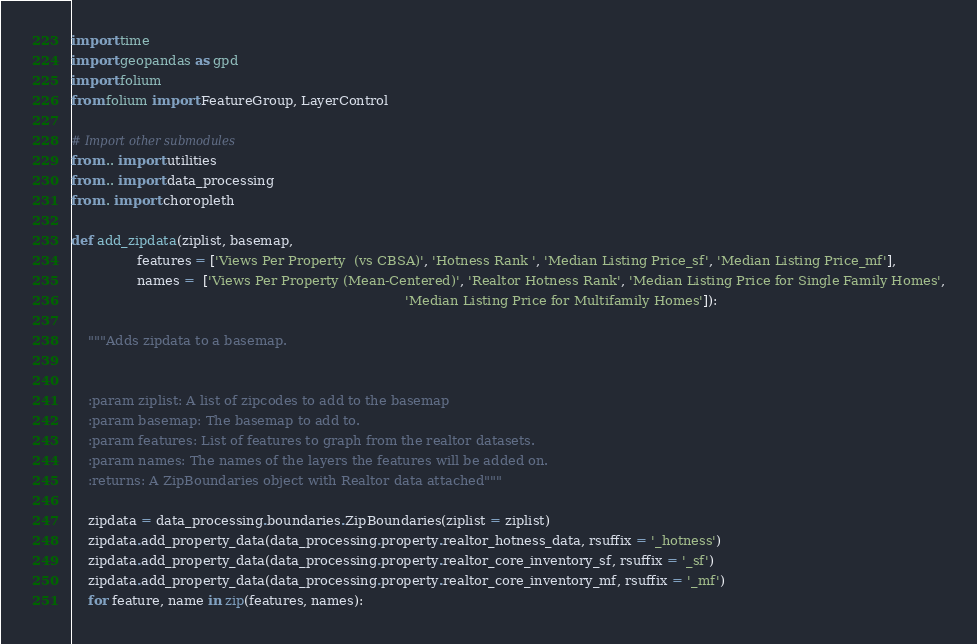<code> <loc_0><loc_0><loc_500><loc_500><_Python_>import time
import geopandas as gpd
import folium
from folium import FeatureGroup, LayerControl

# Import other submodules
from .. import utilities
from .. import data_processing
from . import choropleth

def add_zipdata(ziplist, basemap,
                features = ['Views Per Property  (vs CBSA)', 'Hotness Rank ', 'Median Listing Price_sf', 'Median Listing Price_mf'],
                names =  ['Views Per Property (Mean-Centered)', 'Realtor Hotness Rank', 'Median Listing Price for Single Family Homes',
                                                                                 'Median Listing Price for Multifamily Homes']):

    """Adds zipdata to a basemap.


    :param ziplist: A list of zipcodes to add to the basemap
    :param basemap: The basemap to add to.
    :param features: List of features to graph from the realtor datasets.
    :param names: The names of the layers the features will be added on.
    :returns: A ZipBoundaries object with Realtor data attached"""

    zipdata = data_processing.boundaries.ZipBoundaries(ziplist = ziplist)
    zipdata.add_property_data(data_processing.property.realtor_hotness_data, rsuffix = '_hotness')
    zipdata.add_property_data(data_processing.property.realtor_core_inventory_sf, rsuffix = '_sf')
    zipdata.add_property_data(data_processing.property.realtor_core_inventory_mf, rsuffix = '_mf')
    for feature, name in zip(features, names):</code> 